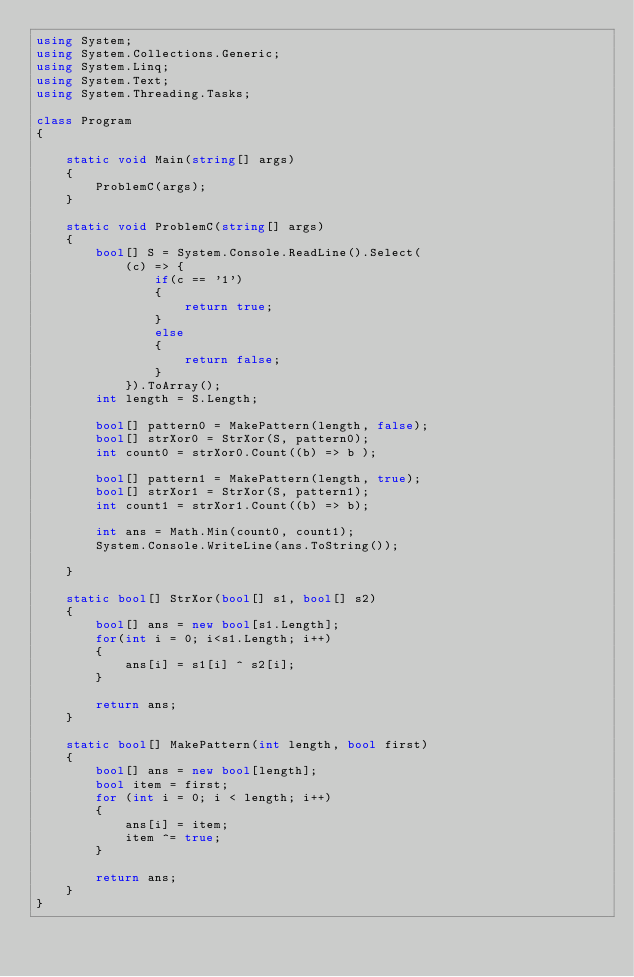<code> <loc_0><loc_0><loc_500><loc_500><_C#_>using System;
using System.Collections.Generic;
using System.Linq;
using System.Text;
using System.Threading.Tasks;

class Program
{

    static void Main(string[] args)
    {
        ProblemC(args);
    }

    static void ProblemC(string[] args)
    {
        bool[] S = System.Console.ReadLine().Select(
            (c) => {
                if(c == '1')
                {
                    return true;
                }
                else
                {
                    return false;
                }
            }).ToArray();
        int length = S.Length;

        bool[] pattern0 = MakePattern(length, false);
        bool[] strXor0 = StrXor(S, pattern0);
        int count0 = strXor0.Count((b) => b );

        bool[] pattern1 = MakePattern(length, true);
        bool[] strXor1 = StrXor(S, pattern1);
        int count1 = strXor1.Count((b) => b);

        int ans = Math.Min(count0, count1);
        System.Console.WriteLine(ans.ToString());

    }

    static bool[] StrXor(bool[] s1, bool[] s2)
    {
        bool[] ans = new bool[s1.Length];
        for(int i = 0; i<s1.Length; i++)
        {
            ans[i] = s1[i] ^ s2[i];
        }

        return ans;
    }

    static bool[] MakePattern(int length, bool first)
    {
        bool[] ans = new bool[length];
        bool item = first;
        for (int i = 0; i < length; i++)
        {
            ans[i] = item;
            item ^= true; 
        }

        return ans;
    }
}</code> 